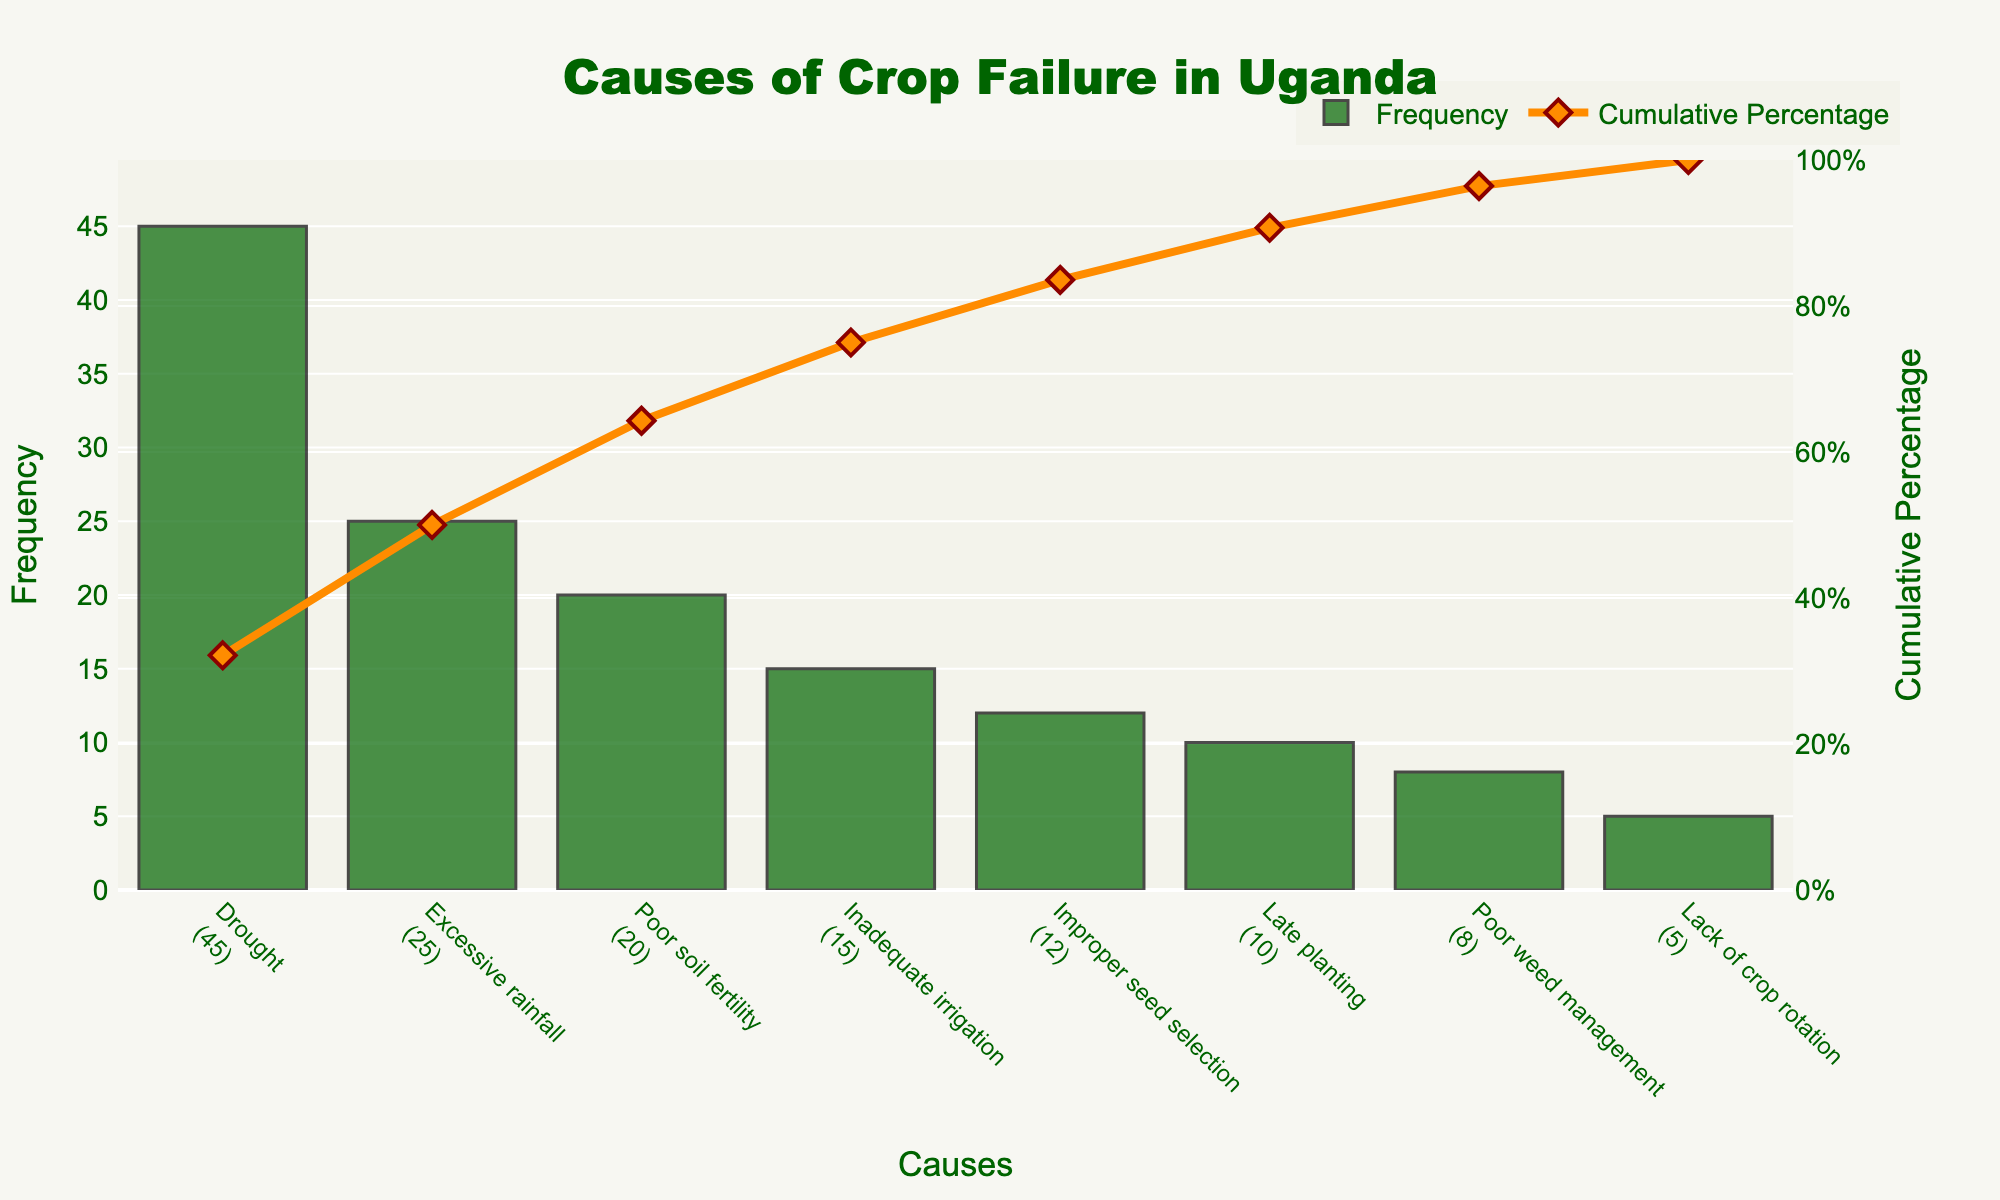What is the title of the figure? The title is located at the top center of the figure and is prominently displayed with a larger font size. The title reads "Causes of Crop Failure in Uganda."
Answer: Causes of Crop Failure in Uganda Which cause of crop failure has the highest frequency? Look at the bar chart to see which bar is the tallest. The tallest bar represents "Drought" with a frequency of 45.
Answer: Drought How many causes have a frequency greater than 10? Identify the bars that have y-values (frequency) greater than 10. The bars for "Drought," "Excessive rainfall," "Poor soil fertility," "Inadequate irrigation," "Improper seed selection," and "Late planting" all meet this criterion. Count them.
Answer: Six What is the cumulative percentage after including the top two causes of crop failure? Check the line representing the cumulative percentage. After "Drought" and "Excessive rainfall," the percentage is approximately 70% (add 45 and 25 to get 70% of the total).
Answer: Approximately 70% Which cause contributes the least to crop failure? The shortest bar represents the cause contributing the least. "Lack of crop rotation" has the shortest bar with a frequency of 5.
Answer: Lack of crop rotation Compare the frequency of "Improper seed selection" to "Late planting." Which one is higher and by how much? Identify the bars for "Improper seed selection" and "Late planting." "Improper seed selection" has a frequency of 12, while "Late planting" has a frequency of 10. Subtract the smaller frequency from the larger one.
Answer: Improper seed selection by 2 What percentage of the total frequency is accounted for by "Poor weed management"? Find the frequency of "Poor weed management," which is 8. Divide 8 by the total frequency (sum of all frequencies: 45+25+20+15+12+10+8+5 = 140) and multiply by 100 to get the percentage.
Answer: Approximately 5.71% What is the combined frequency of the top three causes of crop failure? Add the frequencies of the top three causes: "Drought" (45), "Excessive rainfall" (25), and "Poor soil fertility" (20). Combine these values.
Answer: 90 What does the right y-axis represent, and what is its range? The right y-axis represents the cumulative percentage, as indicated by the title on the axis. The range is from 0% to 100%.
Answer: Cumulative percentage, 0%-100% Are there any causes with equal frequencies? Examine the bars for all causes to see if any have the exact same height. None of the causes have equal frequencies in this chart.
Answer: No 